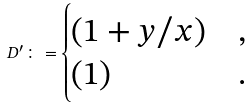Convert formula to latex. <formula><loc_0><loc_0><loc_500><loc_500>D ^ { \prime } \colon = \begin{cases} ( 1 + y / x ) & , \\ ( 1 ) & . \end{cases}</formula> 